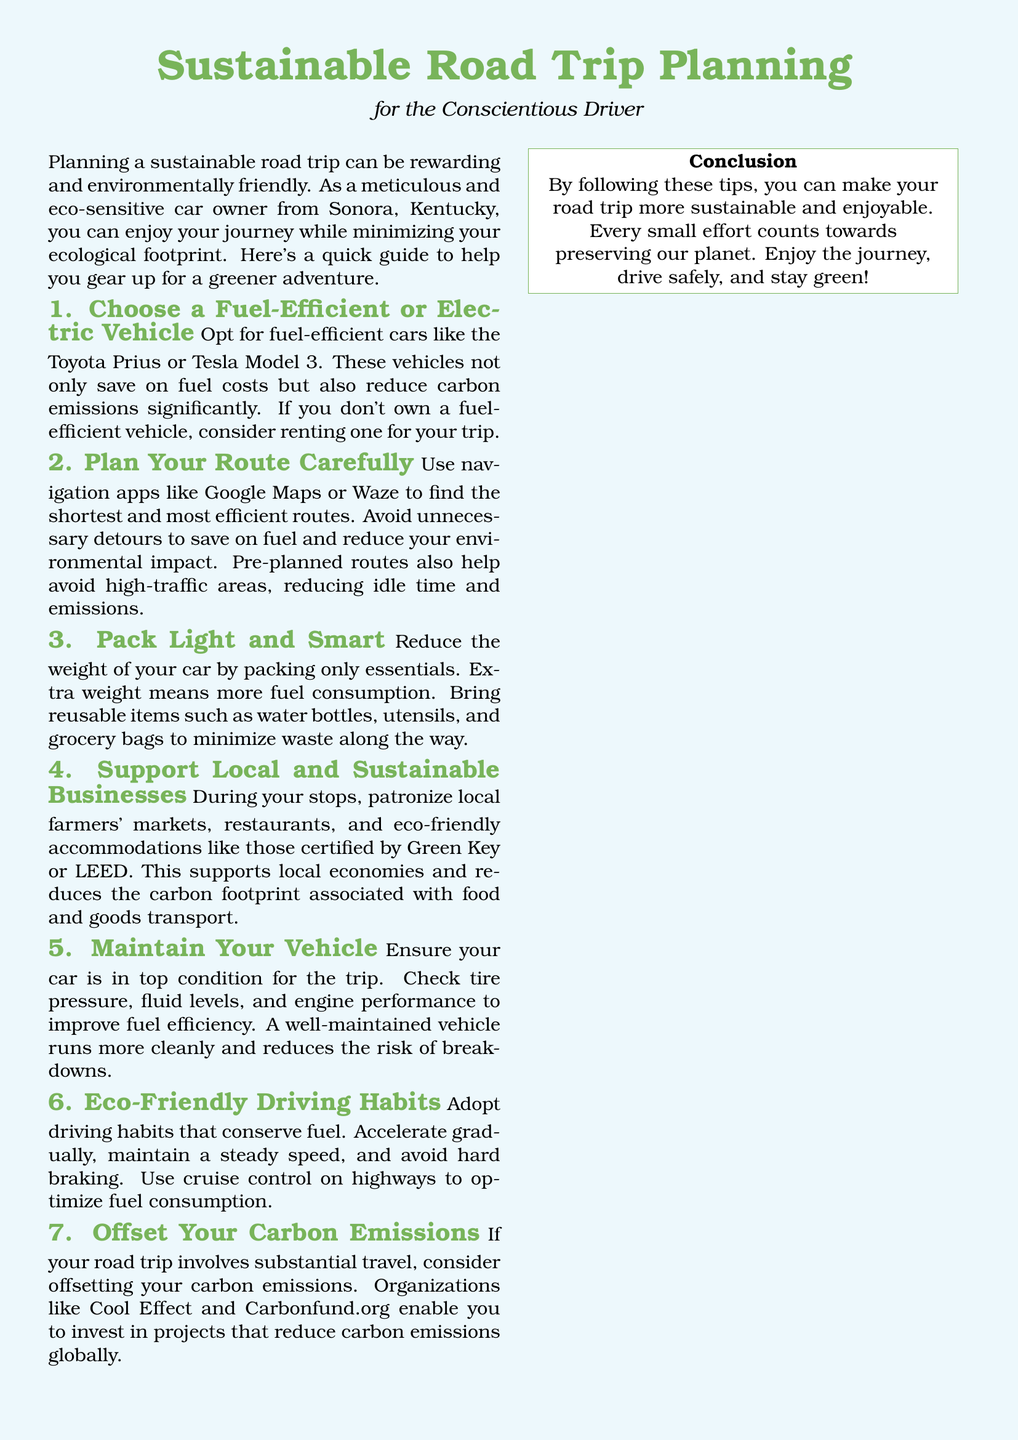What is the main focus of the document? The main focus is on sustainable road trip planning for conscientious drivers, emphasizing eco-friendly practices and tips.
Answer: Sustainable road trip planning What are two examples of fuel-efficient vehicles mentioned? The document lists specific examples of fuel-efficient vehicles to consider for a road trip.
Answer: Toyota Prius, Tesla Model 3 What should you do to maintain vehicle efficiency? Maintaining vehicle efficiency involves checking several aspects to ensure the vehicle operates optimally.
Answer: Check tire pressure, fluid levels, engine performance Name a navigation app recommended in the document. The document suggests using specific apps to plan efficient routes for road trips.
Answer: Google Maps What should you pack to reduce waste? The document advises bringing items that minimize waste during the trip.
Answer: Reusable water bottles, utensils, grocery bags How can you offset your carbon emissions according to the document? The document provides a solution to mitigate the environmental impact of carbon emissions during travel.
Answer: Invest in projects that reduce carbon emissions Why is it important to support local businesses during the trip? Supporting local businesses is beneficial for both environmental and economic reasons mentioned in the document.
Answer: Supports local economies, reduces carbon footprint What driving habit is suggested for fuel conservation? The document recommends a specific driving behavior to achieve better fuel efficiency.
Answer: Accelerate gradually What certification should eco-friendly accommodations hold? The document mentions certifications that signify environmentally sustainable practices in accommodations.
Answer: Green Key, LEED 